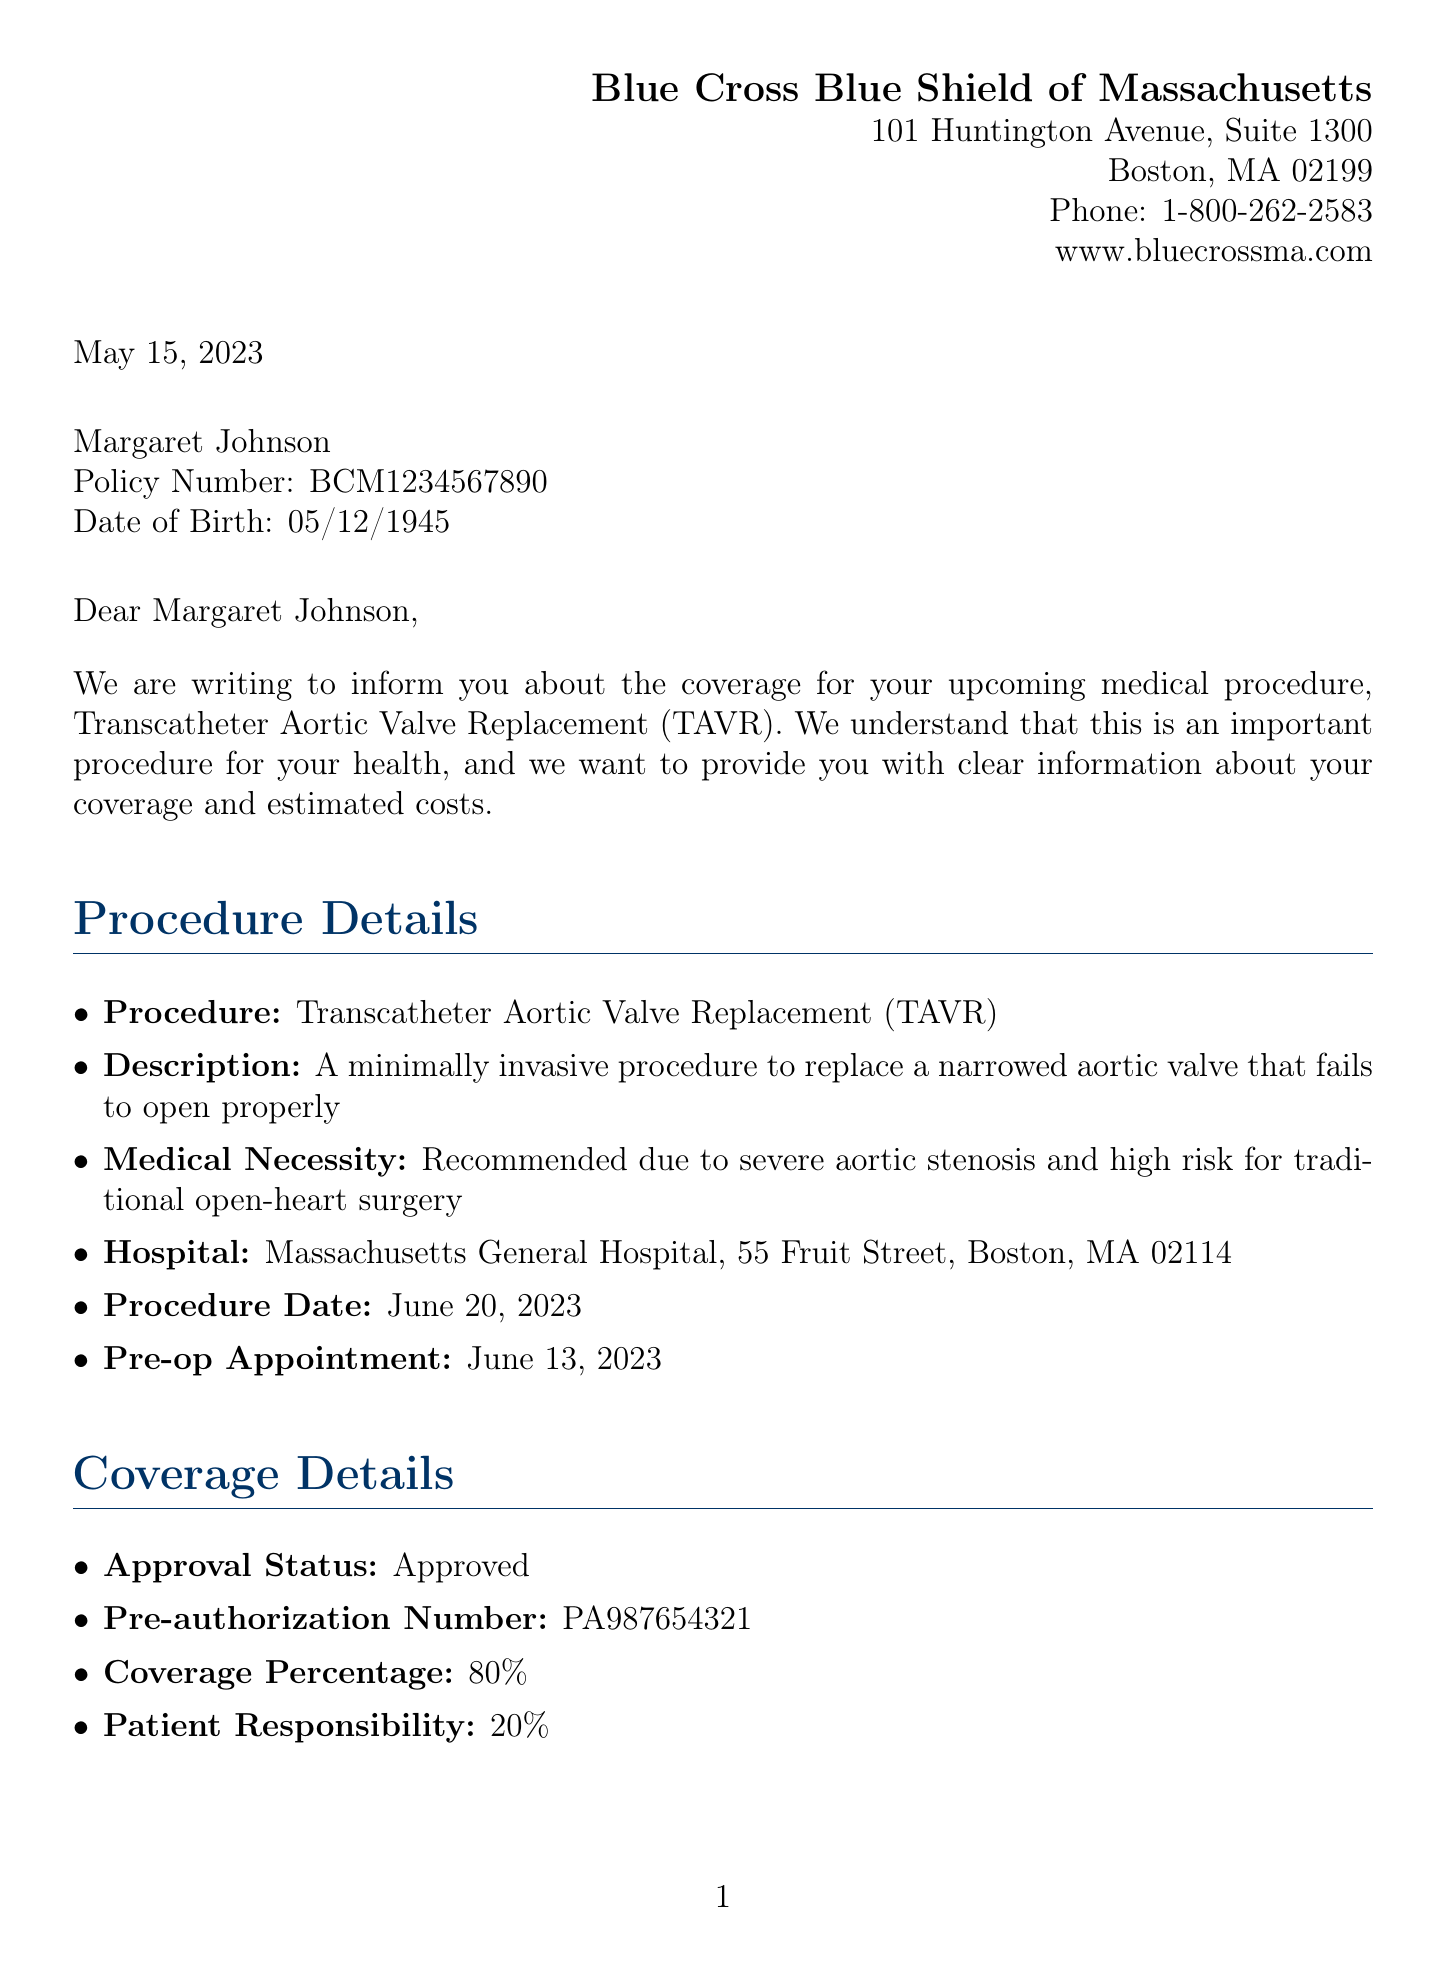What is the name of the procedure? The document clearly states that the procedure is called Transcatheter Aortic Valve Replacement (TAVR).
Answer: Transcatheter Aortic Valve Replacement (TAVR) What is the total procedure cost? According to the document, the total procedure cost is explicitly mentioned as $72,000.
Answer: $72,000 What percentage of the cost will the patient be responsible for? The document specifies that the patient responsibility is 20%.
Answer: 20% What is the approval status of the procedure? The document clearly indicates that the approval status is Approved.
Answer: Approved When is the procedure date scheduled? The document states that the procedure date is June 20, 2023.
Answer: June 20, 2023 Who should be contacted for questions about coverage? The document provides a clear directive to contact Member Services at 1-800-262-2583 for coverage questions.
Answer: 1-800-262-2583 What hospital will perform the procedure? The document specifies that Massachusetts General Hospital will perform the procedure.
Answer: Massachusetts General Hospital What is the pre-authorization number? The document contains the pre-authorization number for the procedure, which is PA987654321.
Answer: PA987654321 What must be provided to the surgical team? The document states that a complete list of current medications must be provided to the surgical team.
Answer: Complete list of current medications 